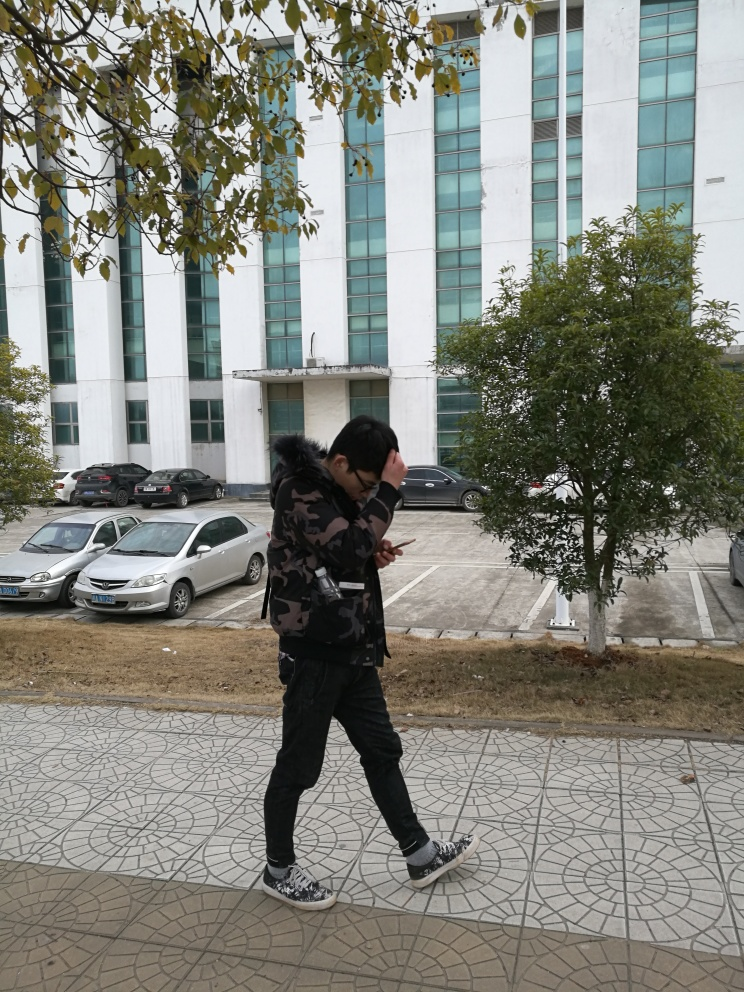Overall, how would you rate the image quality?
A. poor
B. good
C. average
Answer with the option's letter from the given choices directly. The image quality can be considered good (option B). The picture is clear and the subject is in focus. However, there is room for improvement as the image could benefit from better framing and lighting to enhance its visual appeal. 